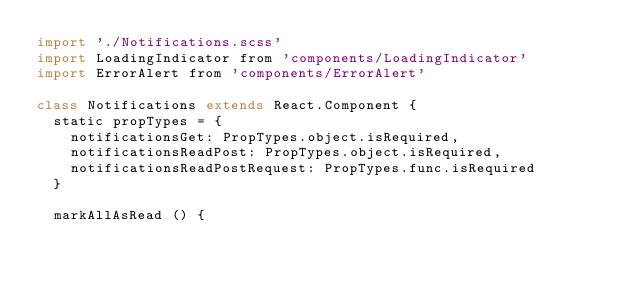Convert code to text. <code><loc_0><loc_0><loc_500><loc_500><_JavaScript_>import './Notifications.scss'
import LoadingIndicator from 'components/LoadingIndicator'
import ErrorAlert from 'components/ErrorAlert'

class Notifications extends React.Component {
  static propTypes = {
    notificationsGet: PropTypes.object.isRequired,
    notificationsReadPost: PropTypes.object.isRequired,
    notificationsReadPostRequest: PropTypes.func.isRequired
  }

  markAllAsRead () {</code> 